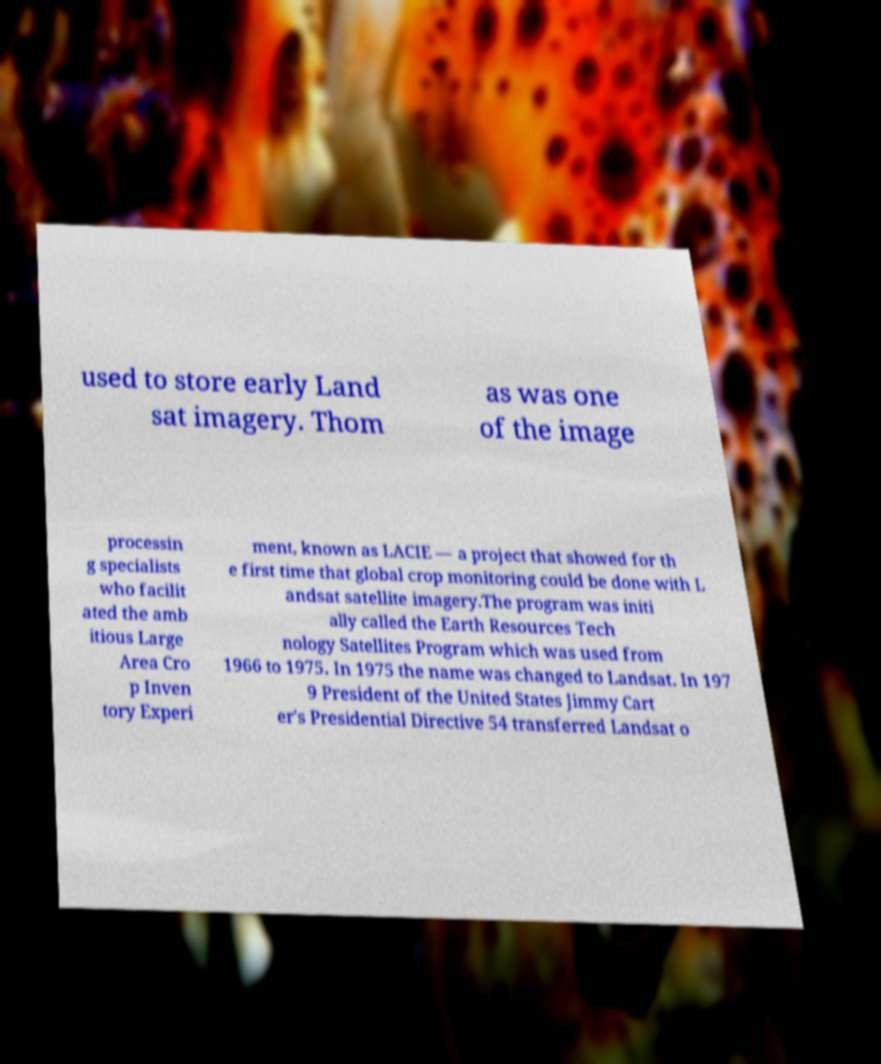Please identify and transcribe the text found in this image. used to store early Land sat imagery. Thom as was one of the image processin g specialists who facilit ated the amb itious Large Area Cro p Inven tory Experi ment, known as LACIE — a project that showed for th e first time that global crop monitoring could be done with L andsat satellite imagery.The program was initi ally called the Earth Resources Tech nology Satellites Program which was used from 1966 to 1975. In 1975 the name was changed to Landsat. In 197 9 President of the United States Jimmy Cart er's Presidential Directive 54 transferred Landsat o 